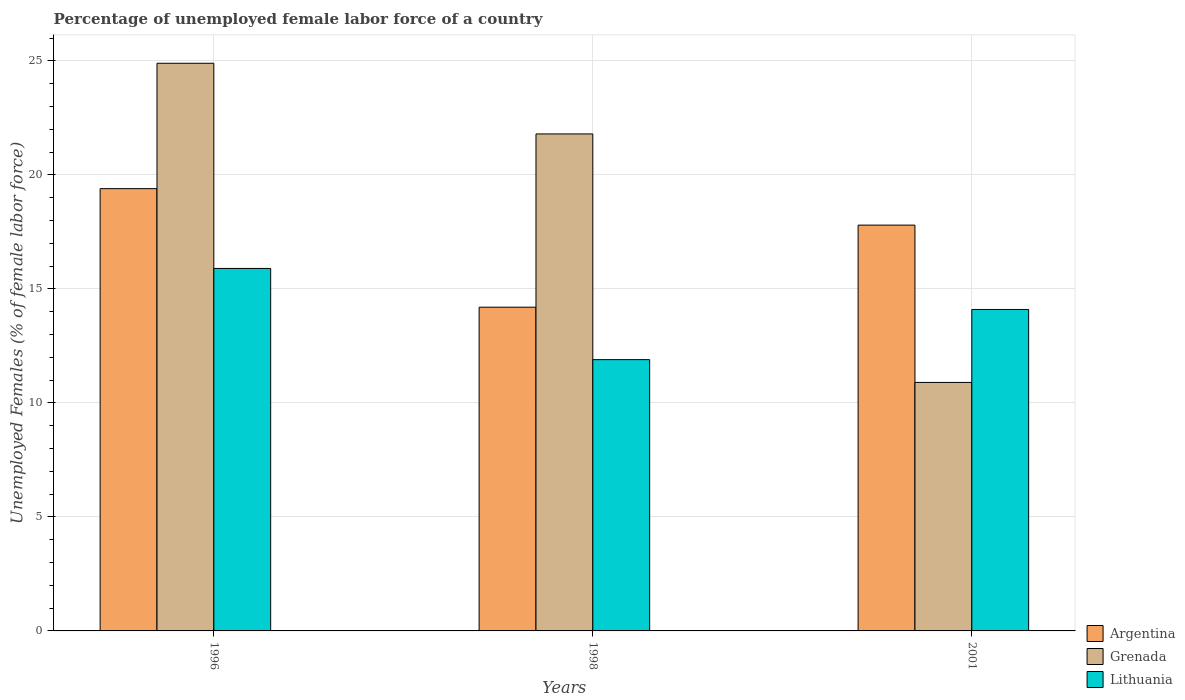How many bars are there on the 3rd tick from the left?
Your response must be concise. 3. What is the percentage of unemployed female labor force in Grenada in 1996?
Offer a very short reply. 24.9. Across all years, what is the maximum percentage of unemployed female labor force in Grenada?
Give a very brief answer. 24.9. Across all years, what is the minimum percentage of unemployed female labor force in Grenada?
Provide a succinct answer. 10.9. In which year was the percentage of unemployed female labor force in Lithuania maximum?
Offer a very short reply. 1996. In which year was the percentage of unemployed female labor force in Argentina minimum?
Keep it short and to the point. 1998. What is the total percentage of unemployed female labor force in Argentina in the graph?
Your response must be concise. 51.4. What is the difference between the percentage of unemployed female labor force in Argentina in 1996 and that in 2001?
Give a very brief answer. 1.6. What is the difference between the percentage of unemployed female labor force in Grenada in 2001 and the percentage of unemployed female labor force in Argentina in 1996?
Your response must be concise. -8.5. What is the average percentage of unemployed female labor force in Grenada per year?
Your answer should be compact. 19.2. In the year 1996, what is the difference between the percentage of unemployed female labor force in Argentina and percentage of unemployed female labor force in Grenada?
Your response must be concise. -5.5. In how many years, is the percentage of unemployed female labor force in Grenada greater than 7 %?
Your answer should be compact. 3. What is the ratio of the percentage of unemployed female labor force in Argentina in 1996 to that in 1998?
Ensure brevity in your answer.  1.37. What is the difference between the highest and the second highest percentage of unemployed female labor force in Argentina?
Offer a very short reply. 1.6. What is the difference between the highest and the lowest percentage of unemployed female labor force in Argentina?
Make the answer very short. 5.2. Is the sum of the percentage of unemployed female labor force in Argentina in 1996 and 1998 greater than the maximum percentage of unemployed female labor force in Grenada across all years?
Provide a short and direct response. Yes. What does the 2nd bar from the left in 1998 represents?
Offer a terse response. Grenada. What does the 2nd bar from the right in 1996 represents?
Give a very brief answer. Grenada. How many bars are there?
Your answer should be very brief. 9. Are all the bars in the graph horizontal?
Provide a short and direct response. No. What is the difference between two consecutive major ticks on the Y-axis?
Offer a terse response. 5. Are the values on the major ticks of Y-axis written in scientific E-notation?
Your answer should be very brief. No. Does the graph contain grids?
Your answer should be compact. Yes. How many legend labels are there?
Keep it short and to the point. 3. How are the legend labels stacked?
Your answer should be very brief. Vertical. What is the title of the graph?
Keep it short and to the point. Percentage of unemployed female labor force of a country. Does "Turks and Caicos Islands" appear as one of the legend labels in the graph?
Ensure brevity in your answer.  No. What is the label or title of the Y-axis?
Make the answer very short. Unemployed Females (% of female labor force). What is the Unemployed Females (% of female labor force) of Argentina in 1996?
Provide a short and direct response. 19.4. What is the Unemployed Females (% of female labor force) in Grenada in 1996?
Provide a short and direct response. 24.9. What is the Unemployed Females (% of female labor force) of Lithuania in 1996?
Provide a succinct answer. 15.9. What is the Unemployed Females (% of female labor force) of Argentina in 1998?
Make the answer very short. 14.2. What is the Unemployed Females (% of female labor force) in Grenada in 1998?
Your answer should be compact. 21.8. What is the Unemployed Females (% of female labor force) of Lithuania in 1998?
Your response must be concise. 11.9. What is the Unemployed Females (% of female labor force) in Argentina in 2001?
Your answer should be very brief. 17.8. What is the Unemployed Females (% of female labor force) of Grenada in 2001?
Offer a terse response. 10.9. What is the Unemployed Females (% of female labor force) in Lithuania in 2001?
Provide a succinct answer. 14.1. Across all years, what is the maximum Unemployed Females (% of female labor force) of Argentina?
Your answer should be very brief. 19.4. Across all years, what is the maximum Unemployed Females (% of female labor force) in Grenada?
Provide a succinct answer. 24.9. Across all years, what is the maximum Unemployed Females (% of female labor force) of Lithuania?
Offer a very short reply. 15.9. Across all years, what is the minimum Unemployed Females (% of female labor force) in Argentina?
Offer a terse response. 14.2. Across all years, what is the minimum Unemployed Females (% of female labor force) of Grenada?
Offer a terse response. 10.9. Across all years, what is the minimum Unemployed Females (% of female labor force) in Lithuania?
Make the answer very short. 11.9. What is the total Unemployed Females (% of female labor force) in Argentina in the graph?
Keep it short and to the point. 51.4. What is the total Unemployed Females (% of female labor force) of Grenada in the graph?
Offer a very short reply. 57.6. What is the total Unemployed Females (% of female labor force) of Lithuania in the graph?
Provide a succinct answer. 41.9. What is the difference between the Unemployed Females (% of female labor force) in Grenada in 1996 and that in 1998?
Make the answer very short. 3.1. What is the difference between the Unemployed Females (% of female labor force) of Lithuania in 1996 and that in 1998?
Give a very brief answer. 4. What is the difference between the Unemployed Females (% of female labor force) of Argentina in 1996 and that in 2001?
Make the answer very short. 1.6. What is the difference between the Unemployed Females (% of female labor force) in Grenada in 1996 and that in 2001?
Ensure brevity in your answer.  14. What is the difference between the Unemployed Females (% of female labor force) of Argentina in 1998 and that in 2001?
Give a very brief answer. -3.6. What is the difference between the Unemployed Females (% of female labor force) in Lithuania in 1998 and that in 2001?
Make the answer very short. -2.2. What is the difference between the Unemployed Females (% of female labor force) in Argentina in 1996 and the Unemployed Females (% of female labor force) in Grenada in 1998?
Your answer should be very brief. -2.4. What is the difference between the Unemployed Females (% of female labor force) of Grenada in 1996 and the Unemployed Females (% of female labor force) of Lithuania in 1998?
Your response must be concise. 13. What is the difference between the Unemployed Females (% of female labor force) in Argentina in 1996 and the Unemployed Females (% of female labor force) in Grenada in 2001?
Ensure brevity in your answer.  8.5. What is the difference between the Unemployed Females (% of female labor force) in Argentina in 1996 and the Unemployed Females (% of female labor force) in Lithuania in 2001?
Keep it short and to the point. 5.3. What is the difference between the Unemployed Females (% of female labor force) of Grenada in 1996 and the Unemployed Females (% of female labor force) of Lithuania in 2001?
Provide a short and direct response. 10.8. What is the difference between the Unemployed Females (% of female labor force) in Grenada in 1998 and the Unemployed Females (% of female labor force) in Lithuania in 2001?
Keep it short and to the point. 7.7. What is the average Unemployed Females (% of female labor force) in Argentina per year?
Your answer should be very brief. 17.13. What is the average Unemployed Females (% of female labor force) of Grenada per year?
Ensure brevity in your answer.  19.2. What is the average Unemployed Females (% of female labor force) in Lithuania per year?
Make the answer very short. 13.97. In the year 1996, what is the difference between the Unemployed Females (% of female labor force) of Argentina and Unemployed Females (% of female labor force) of Grenada?
Offer a very short reply. -5.5. In the year 1996, what is the difference between the Unemployed Females (% of female labor force) in Argentina and Unemployed Females (% of female labor force) in Lithuania?
Give a very brief answer. 3.5. In the year 1998, what is the difference between the Unemployed Females (% of female labor force) of Argentina and Unemployed Females (% of female labor force) of Grenada?
Your response must be concise. -7.6. In the year 2001, what is the difference between the Unemployed Females (% of female labor force) of Argentina and Unemployed Females (% of female labor force) of Grenada?
Keep it short and to the point. 6.9. In the year 2001, what is the difference between the Unemployed Females (% of female labor force) in Argentina and Unemployed Females (% of female labor force) in Lithuania?
Offer a very short reply. 3.7. In the year 2001, what is the difference between the Unemployed Females (% of female labor force) in Grenada and Unemployed Females (% of female labor force) in Lithuania?
Offer a very short reply. -3.2. What is the ratio of the Unemployed Females (% of female labor force) in Argentina in 1996 to that in 1998?
Offer a terse response. 1.37. What is the ratio of the Unemployed Females (% of female labor force) of Grenada in 1996 to that in 1998?
Give a very brief answer. 1.14. What is the ratio of the Unemployed Females (% of female labor force) in Lithuania in 1996 to that in 1998?
Keep it short and to the point. 1.34. What is the ratio of the Unemployed Females (% of female labor force) in Argentina in 1996 to that in 2001?
Offer a very short reply. 1.09. What is the ratio of the Unemployed Females (% of female labor force) in Grenada in 1996 to that in 2001?
Give a very brief answer. 2.28. What is the ratio of the Unemployed Females (% of female labor force) in Lithuania in 1996 to that in 2001?
Provide a short and direct response. 1.13. What is the ratio of the Unemployed Females (% of female labor force) of Argentina in 1998 to that in 2001?
Provide a short and direct response. 0.8. What is the ratio of the Unemployed Females (% of female labor force) of Grenada in 1998 to that in 2001?
Ensure brevity in your answer.  2. What is the ratio of the Unemployed Females (% of female labor force) in Lithuania in 1998 to that in 2001?
Offer a terse response. 0.84. What is the difference between the highest and the second highest Unemployed Females (% of female labor force) of Argentina?
Provide a succinct answer. 1.6. What is the difference between the highest and the second highest Unemployed Females (% of female labor force) of Lithuania?
Make the answer very short. 1.8. What is the difference between the highest and the lowest Unemployed Females (% of female labor force) of Grenada?
Your answer should be very brief. 14. 